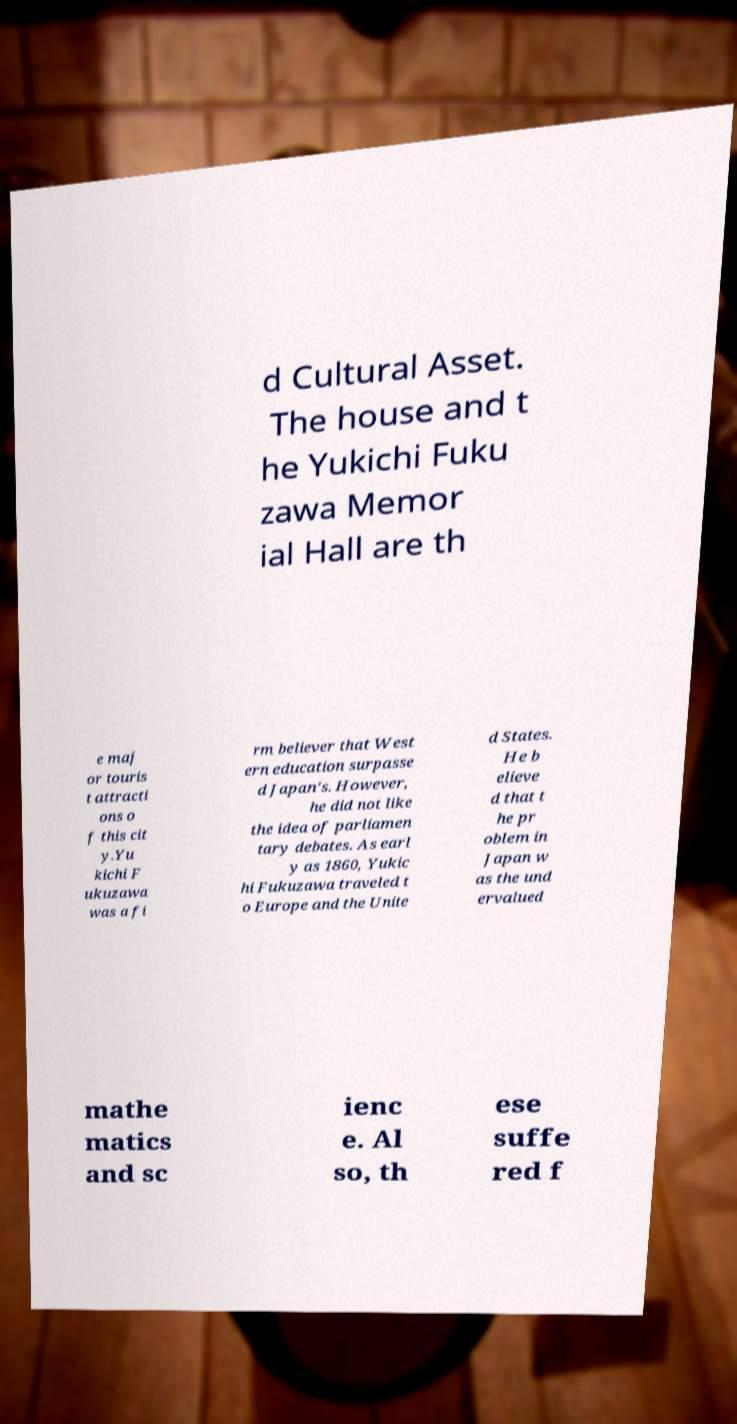Can you read and provide the text displayed in the image?This photo seems to have some interesting text. Can you extract and type it out for me? d Cultural Asset. The house and t he Yukichi Fuku zawa Memor ial Hall are th e maj or touris t attracti ons o f this cit y.Yu kichi F ukuzawa was a fi rm believer that West ern education surpasse d Japan's. However, he did not like the idea of parliamen tary debates. As earl y as 1860, Yukic hi Fukuzawa traveled t o Europe and the Unite d States. He b elieve d that t he pr oblem in Japan w as the und ervalued mathe matics and sc ienc e. Al so, th ese suffe red f 